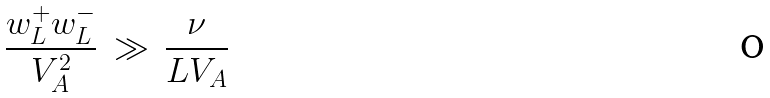Convert formula to latex. <formula><loc_0><loc_0><loc_500><loc_500>\frac { w _ { L } ^ { + } w _ { L } ^ { - } } { V _ { A } ^ { 2 } } \, \gg \, \frac { \nu } { L V _ { A } }</formula> 